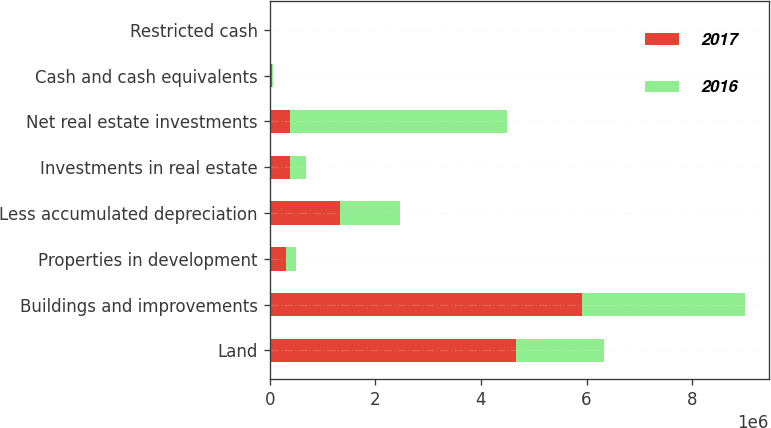<chart> <loc_0><loc_0><loc_500><loc_500><stacked_bar_chart><ecel><fcel>Land<fcel>Buildings and improvements<fcel>Properties in development<fcel>Less accumulated depreciation<fcel>Investments in real estate<fcel>Net real estate investments<fcel>Cash and cash equivalents<fcel>Restricted cash<nl><fcel>2017<fcel>4.66774e+06<fcel>5.91069e+06<fcel>314391<fcel>1.33977e+06<fcel>386304<fcel>386304<fcel>45370<fcel>4011<nl><fcel>2016<fcel>1.66042e+06<fcel>3.0922e+06<fcel>180878<fcel>1.12439e+06<fcel>296699<fcel>4.10581e+06<fcel>13256<fcel>4623<nl></chart> 